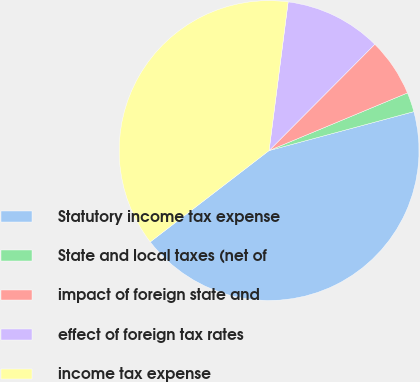<chart> <loc_0><loc_0><loc_500><loc_500><pie_chart><fcel>Statutory income tax expense<fcel>State and local taxes (net of<fcel>impact of foreign state and<fcel>effect of foreign tax rates<fcel>income tax expense<nl><fcel>43.75%<fcel>2.1%<fcel>6.26%<fcel>10.43%<fcel>37.46%<nl></chart> 